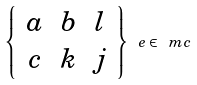<formula> <loc_0><loc_0><loc_500><loc_500>\left \{ \begin{array} { c c c } a & b & l \\ c & k & j \end{array} \right \} _ { \ } e \in \ m c</formula> 